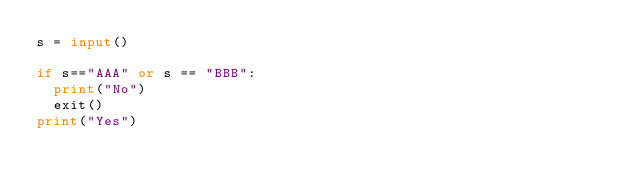Convert code to text. <code><loc_0><loc_0><loc_500><loc_500><_Python_>s = input()

if s=="AAA" or s == "BBB":
  print("No")
  exit()
print("Yes")</code> 